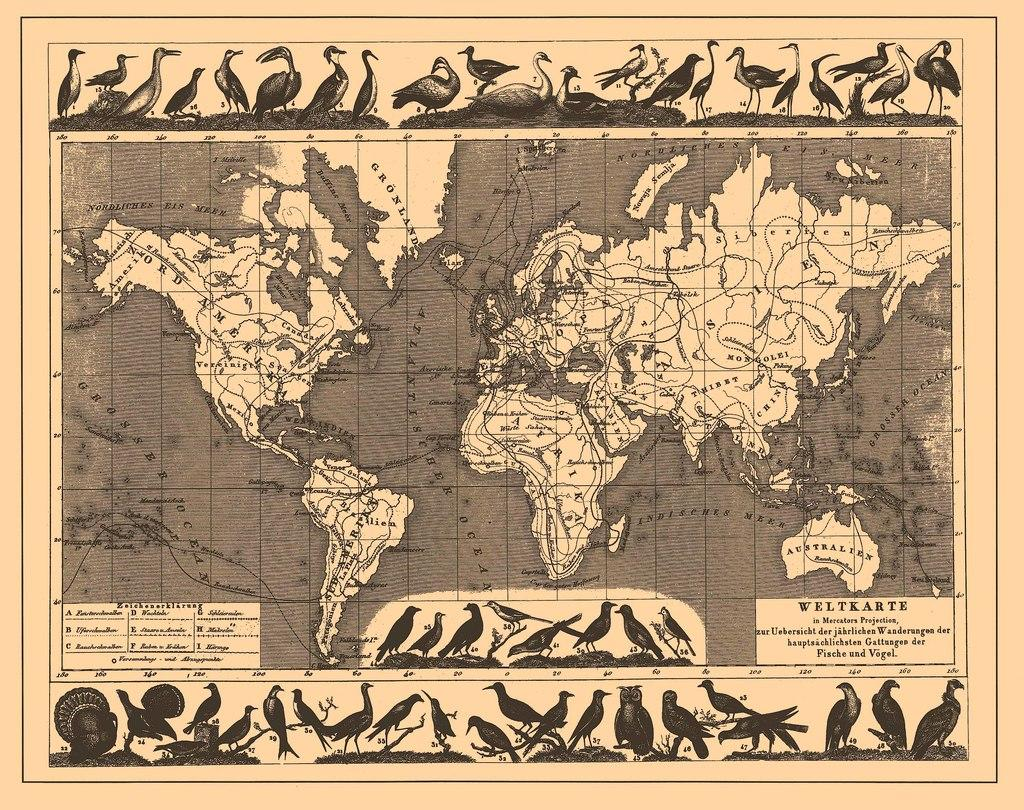Provide a one-sentence caption for the provided image. A map of the world spells Amerika with a K. 